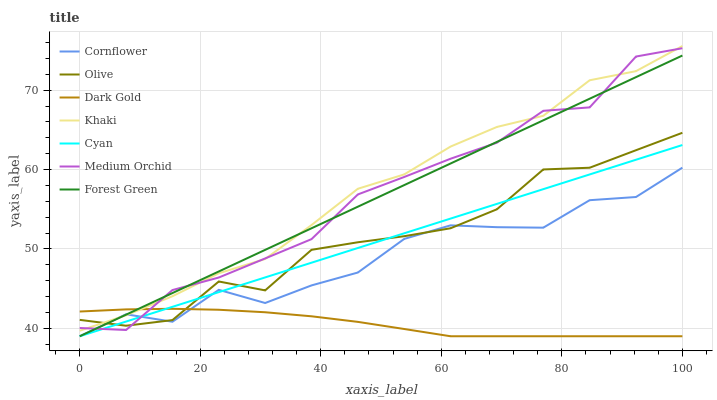Does Dark Gold have the minimum area under the curve?
Answer yes or no. Yes. Does Khaki have the maximum area under the curve?
Answer yes or no. Yes. Does Khaki have the minimum area under the curve?
Answer yes or no. No. Does Dark Gold have the maximum area under the curve?
Answer yes or no. No. Is Cyan the smoothest?
Answer yes or no. Yes. Is Cornflower the roughest?
Answer yes or no. Yes. Is Khaki the smoothest?
Answer yes or no. No. Is Khaki the roughest?
Answer yes or no. No. Does Cornflower have the lowest value?
Answer yes or no. Yes. Does Khaki have the lowest value?
Answer yes or no. No. Does Khaki have the highest value?
Answer yes or no. Yes. Does Dark Gold have the highest value?
Answer yes or no. No. Is Cyan less than Khaki?
Answer yes or no. Yes. Is Khaki greater than Cyan?
Answer yes or no. Yes. Does Medium Orchid intersect Cyan?
Answer yes or no. Yes. Is Medium Orchid less than Cyan?
Answer yes or no. No. Is Medium Orchid greater than Cyan?
Answer yes or no. No. Does Cyan intersect Khaki?
Answer yes or no. No. 